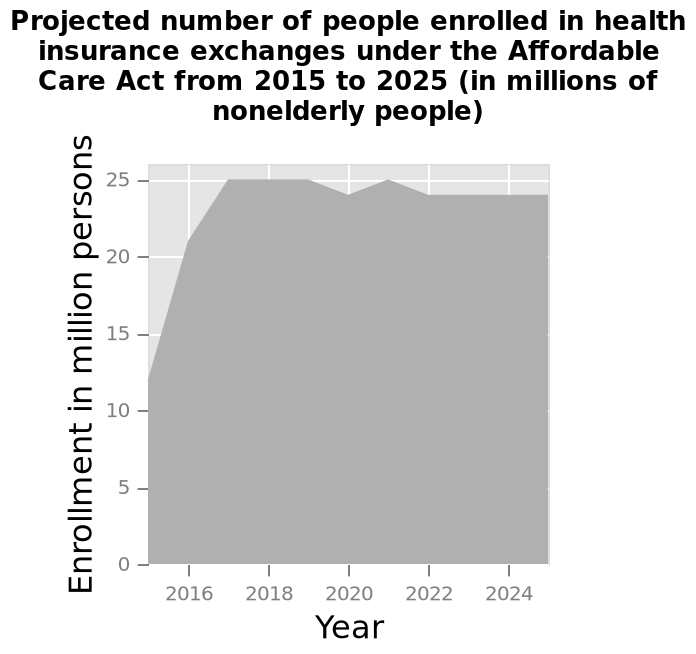<image>
please summary the statistics and relations of the chart The projected number of people enrolled in health insurance between 2017 and 2024 averages 24 Million people. Between 2015 and 2017 the number of people who enrolled rose my roughly 12 million. What is the time period covered by the graph? The graph covers the years from 2015 to 2025. 